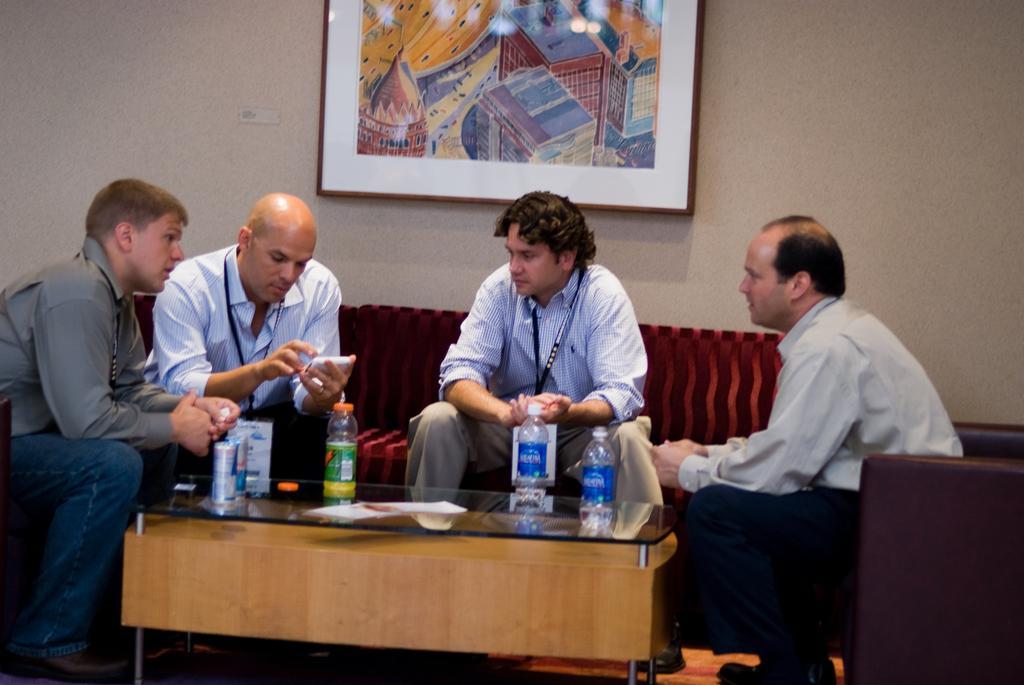In one or two sentences, can you explain what this image depicts? In this image we can see four persons are sitting on the sofa around the table. There are few bottles and tins on the table. In the background we can see a photo frame on the wall. 